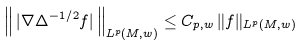<formula> <loc_0><loc_0><loc_500><loc_500>\left \| \, | \nabla \Delta ^ { - 1 / 2 } f | \, \right \| _ { L ^ { p } ( M , w ) } \leq C _ { p , w } \, \| f \| _ { L ^ { p } ( M , w ) }</formula> 